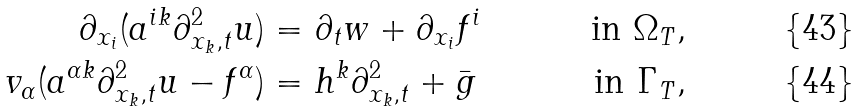Convert formula to latex. <formula><loc_0><loc_0><loc_500><loc_500>\partial _ { x _ { i } } ( a ^ { i k } \partial ^ { 2 } _ { x _ { k } , t } u ) & = \partial _ { t } w + \partial _ { x _ { i } } f ^ { i } & \text { in } \Omega _ { T } , \\ v _ { \alpha } ( a ^ { \alpha k } \partial ^ { 2 } _ { x _ { k } , t } u - f ^ { \alpha } ) & = h ^ { k } \partial ^ { 2 } _ { x _ { k } , t } + \bar { g } & \text { in } \Gamma _ { T } ,</formula> 